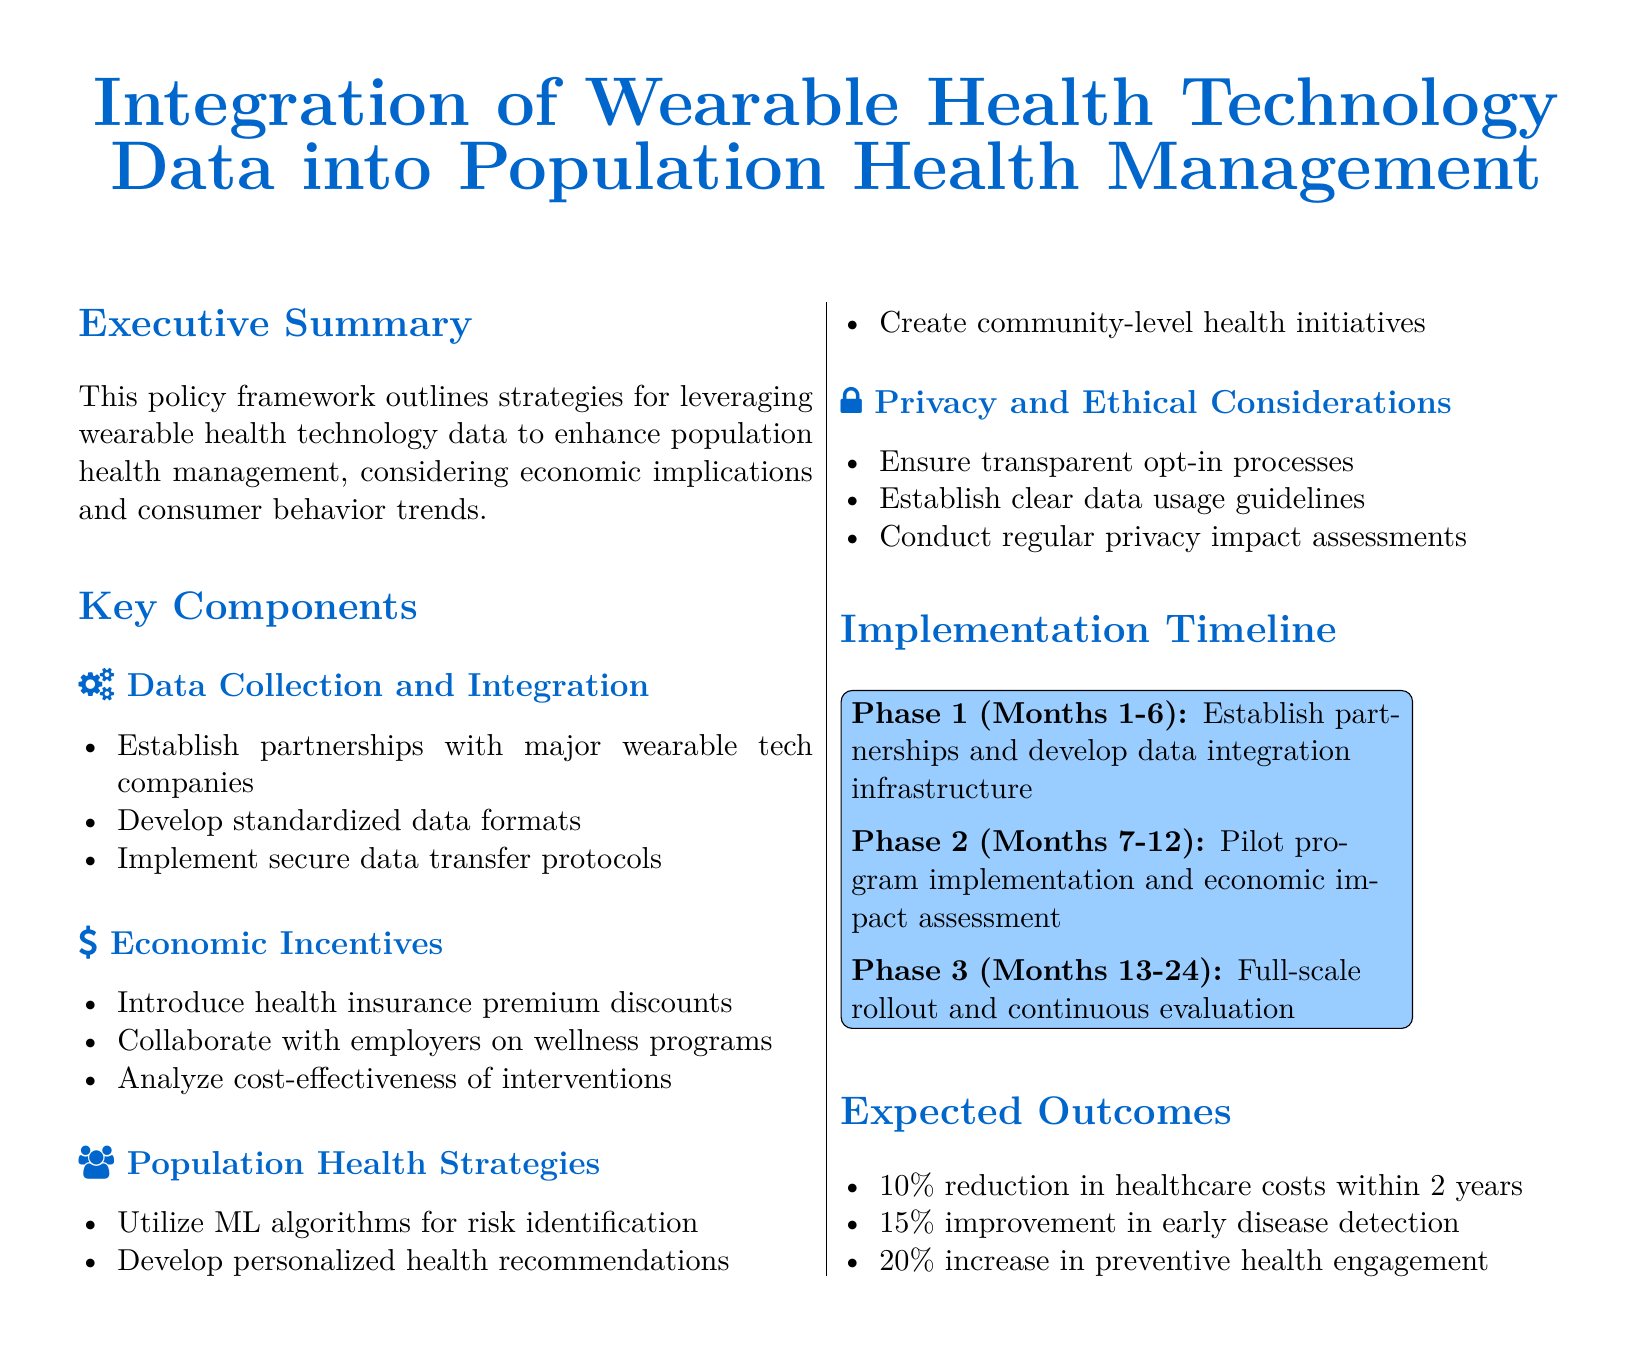What is the title of the document? The title is found in the header section of the document, summarizing its focus.
Answer: Integration of Wearable Health Technology Data into Population Health Management What is the main purpose of this policy framework? The purpose is described in the Executive Summary section, outlining the framework's intent.
Answer: Enhance population health management How long is the implementation timeline in the document? The timeline is detailed in the Implementation Timeline section, specifying the duration of actions.
Answer: 24 months What is the expected reduction in healthcare costs? The expected outcome is stated in the Expected Outcomes section, providing specific targets.
Answer: 10 percent What type of algorithms will be utilized for risk identification? This information is specified under the Population Health Strategies section of the document.
Answer: ML algorithms What phase involves pilot program implementation? The phases are outlined in the Implementation Timeline section, detailing the specific activities in each phase.
Answer: Phase 2 (Months 7-12) What is the first step in data collection and integration? The action is listed in the Key Components section under Data Collection and Integration.
Answer: Establish partnerships with major wearable tech companies What percentage improvement is expected in early disease detection? This target is highlighted in the Expected Outcomes section along with other anticipated outcomes.
Answer: 15 percent 